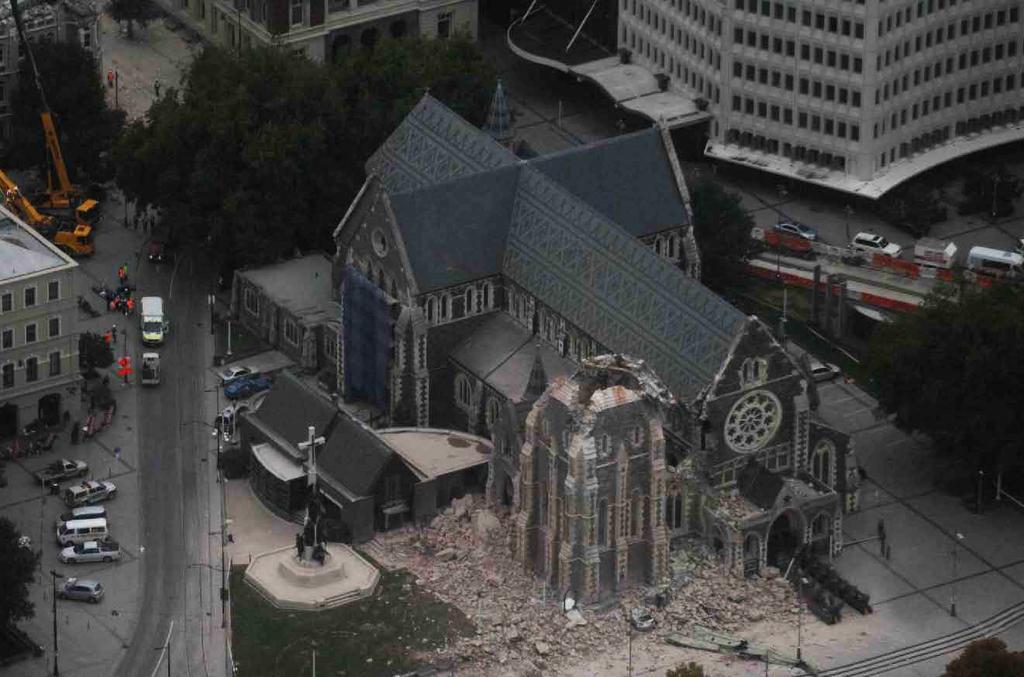In one or two sentences, can you explain what this image depicts? In the image we can see some buildings and trees and poles and there are some vehicles on the road. 